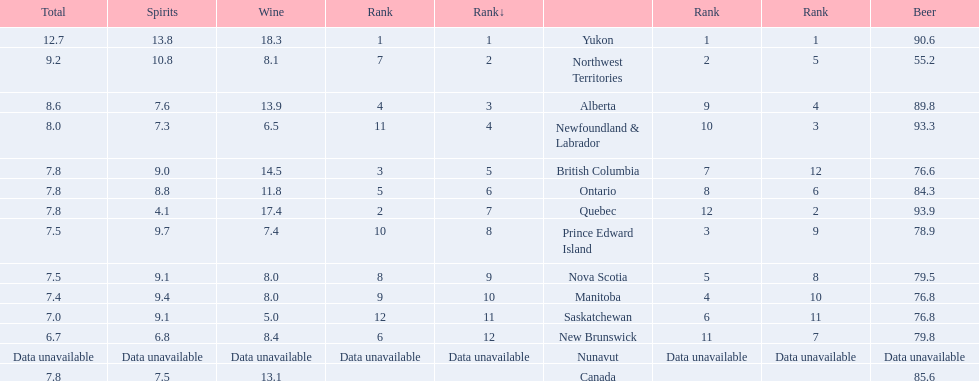Which locations consume the same total amount of alcoholic beverages as another location? British Columbia, Ontario, Quebec, Prince Edward Island, Nova Scotia. Which of these consumes more then 80 of beer? Ontario, Quebec. Of those what was the consumption of spirits of the one that consumed the most beer? 4.1. 